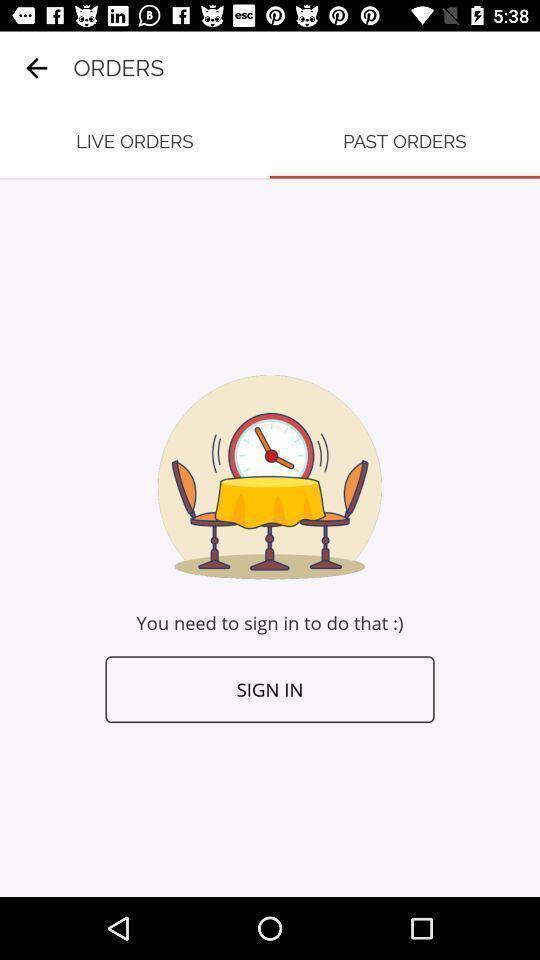Tell me what you see in this picture. Sign in page for an application. 